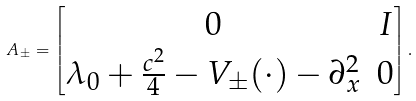Convert formula to latex. <formula><loc_0><loc_0><loc_500><loc_500>A _ { \pm } = \begin{bmatrix} 0 & I \\ \lambda _ { 0 } + \frac { c ^ { 2 } } { 4 } - V _ { \pm } ( \cdot ) - \partial _ { x } ^ { 2 } & 0 \end{bmatrix} .</formula> 